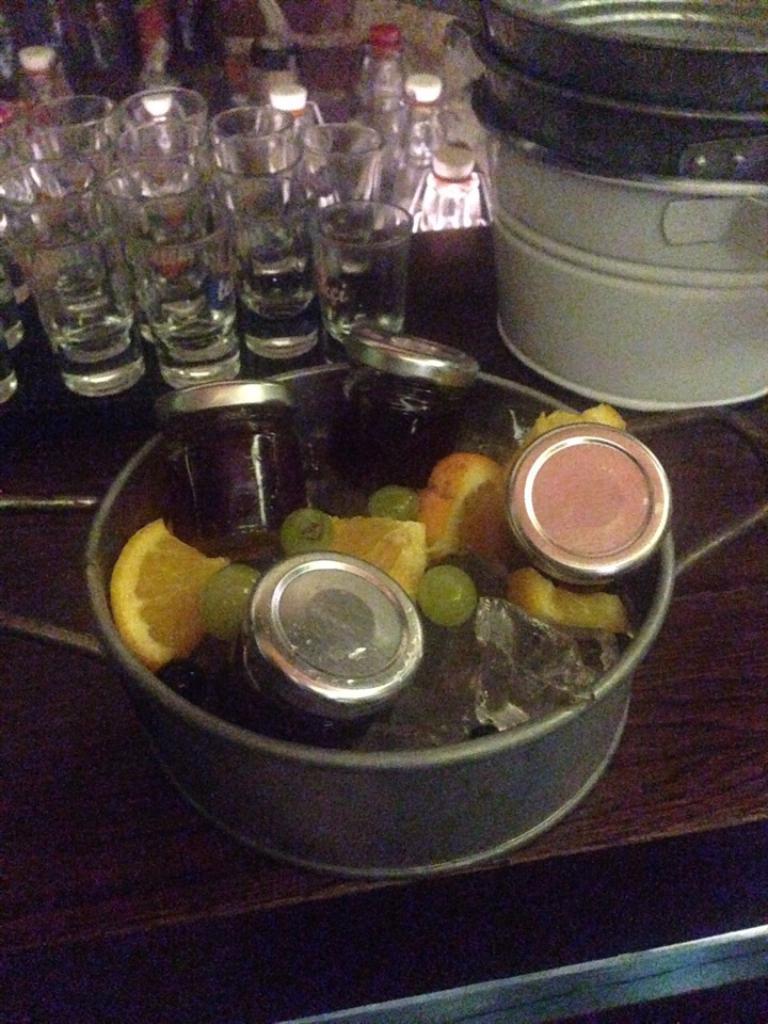In one or two sentences, can you explain what this image depicts? In the picture I can see some jars and fruits are kept in the container and which is placed on the wooden surface. In the background, we can see a few more containers and many glasses and bottles are placed on the wooden table. 